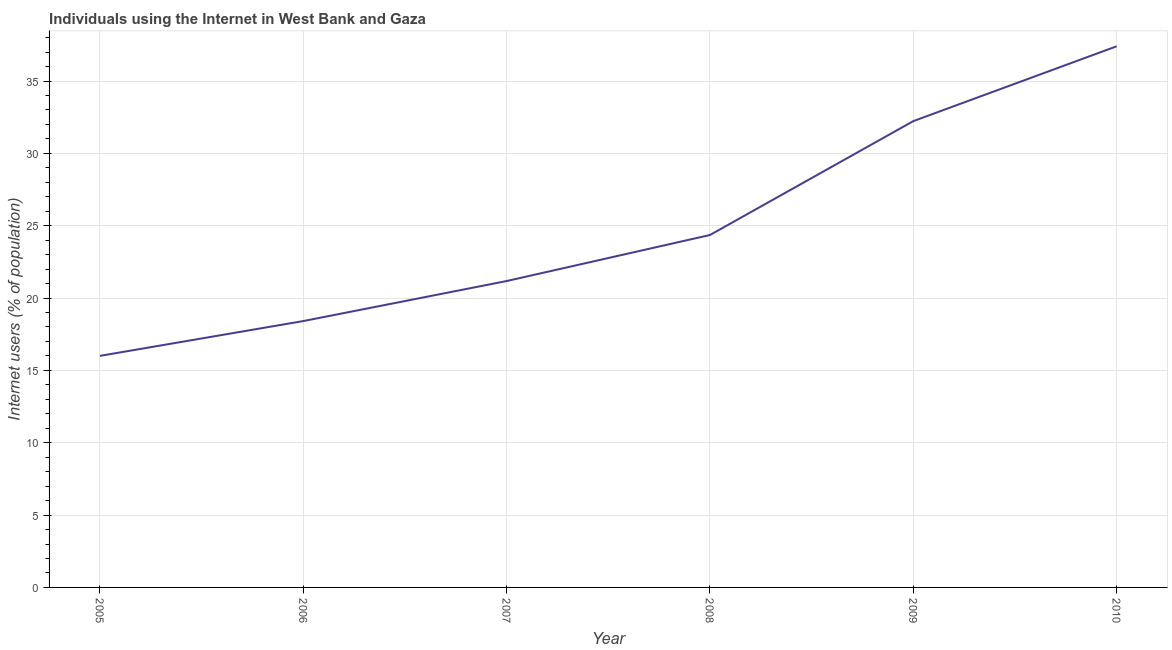What is the number of internet users in 2007?
Offer a very short reply. 21.18. Across all years, what is the maximum number of internet users?
Give a very brief answer. 37.4. Across all years, what is the minimum number of internet users?
Give a very brief answer. 16. In which year was the number of internet users maximum?
Your answer should be very brief. 2010. What is the sum of the number of internet users?
Offer a very short reply. 149.58. What is the difference between the number of internet users in 2007 and 2010?
Provide a short and direct response. -16.22. What is the average number of internet users per year?
Provide a short and direct response. 24.93. What is the median number of internet users?
Provide a succinct answer. 22.77. In how many years, is the number of internet users greater than 19 %?
Provide a short and direct response. 4. Do a majority of the years between 2010 and 2007 (inclusive) have number of internet users greater than 5 %?
Provide a short and direct response. Yes. What is the ratio of the number of internet users in 2005 to that in 2006?
Give a very brief answer. 0.87. Is the difference between the number of internet users in 2009 and 2010 greater than the difference between any two years?
Provide a succinct answer. No. What is the difference between the highest and the second highest number of internet users?
Offer a terse response. 5.17. What is the difference between the highest and the lowest number of internet users?
Make the answer very short. 21.39. In how many years, is the number of internet users greater than the average number of internet users taken over all years?
Provide a succinct answer. 2. Does the number of internet users monotonically increase over the years?
Provide a short and direct response. Yes. How many years are there in the graph?
Provide a short and direct response. 6. Are the values on the major ticks of Y-axis written in scientific E-notation?
Offer a terse response. No. Does the graph contain any zero values?
Ensure brevity in your answer.  No. Does the graph contain grids?
Your answer should be compact. Yes. What is the title of the graph?
Keep it short and to the point. Individuals using the Internet in West Bank and Gaza. What is the label or title of the Y-axis?
Ensure brevity in your answer.  Internet users (% of population). What is the Internet users (% of population) in 2005?
Your response must be concise. 16. What is the Internet users (% of population) in 2006?
Provide a succinct answer. 18.41. What is the Internet users (% of population) of 2007?
Provide a succinct answer. 21.18. What is the Internet users (% of population) of 2008?
Your response must be concise. 24.36. What is the Internet users (% of population) in 2009?
Give a very brief answer. 32.23. What is the Internet users (% of population) of 2010?
Offer a very short reply. 37.4. What is the difference between the Internet users (% of population) in 2005 and 2006?
Your answer should be very brief. -2.4. What is the difference between the Internet users (% of population) in 2005 and 2007?
Provide a succinct answer. -5.17. What is the difference between the Internet users (% of population) in 2005 and 2008?
Ensure brevity in your answer.  -8.35. What is the difference between the Internet users (% of population) in 2005 and 2009?
Make the answer very short. -16.23. What is the difference between the Internet users (% of population) in 2005 and 2010?
Your answer should be very brief. -21.39. What is the difference between the Internet users (% of population) in 2006 and 2007?
Make the answer very short. -2.77. What is the difference between the Internet users (% of population) in 2006 and 2008?
Your answer should be very brief. -5.95. What is the difference between the Internet users (% of population) in 2006 and 2009?
Keep it short and to the point. -13.82. What is the difference between the Internet users (% of population) in 2006 and 2010?
Your response must be concise. -18.99. What is the difference between the Internet users (% of population) in 2007 and 2008?
Offer a very short reply. -3.18. What is the difference between the Internet users (% of population) in 2007 and 2009?
Offer a very short reply. -11.05. What is the difference between the Internet users (% of population) in 2007 and 2010?
Ensure brevity in your answer.  -16.22. What is the difference between the Internet users (% of population) in 2008 and 2009?
Keep it short and to the point. -7.87. What is the difference between the Internet users (% of population) in 2008 and 2010?
Keep it short and to the point. -13.04. What is the difference between the Internet users (% of population) in 2009 and 2010?
Provide a succinct answer. -5.17. What is the ratio of the Internet users (% of population) in 2005 to that in 2006?
Give a very brief answer. 0.87. What is the ratio of the Internet users (% of population) in 2005 to that in 2007?
Provide a short and direct response. 0.76. What is the ratio of the Internet users (% of population) in 2005 to that in 2008?
Keep it short and to the point. 0.66. What is the ratio of the Internet users (% of population) in 2005 to that in 2009?
Offer a terse response. 0.5. What is the ratio of the Internet users (% of population) in 2005 to that in 2010?
Provide a short and direct response. 0.43. What is the ratio of the Internet users (% of population) in 2006 to that in 2007?
Make the answer very short. 0.87. What is the ratio of the Internet users (% of population) in 2006 to that in 2008?
Provide a succinct answer. 0.76. What is the ratio of the Internet users (% of population) in 2006 to that in 2009?
Offer a very short reply. 0.57. What is the ratio of the Internet users (% of population) in 2006 to that in 2010?
Provide a short and direct response. 0.49. What is the ratio of the Internet users (% of population) in 2007 to that in 2008?
Offer a very short reply. 0.87. What is the ratio of the Internet users (% of population) in 2007 to that in 2009?
Your response must be concise. 0.66. What is the ratio of the Internet users (% of population) in 2007 to that in 2010?
Make the answer very short. 0.57. What is the ratio of the Internet users (% of population) in 2008 to that in 2009?
Offer a very short reply. 0.76. What is the ratio of the Internet users (% of population) in 2008 to that in 2010?
Provide a short and direct response. 0.65. What is the ratio of the Internet users (% of population) in 2009 to that in 2010?
Your response must be concise. 0.86. 